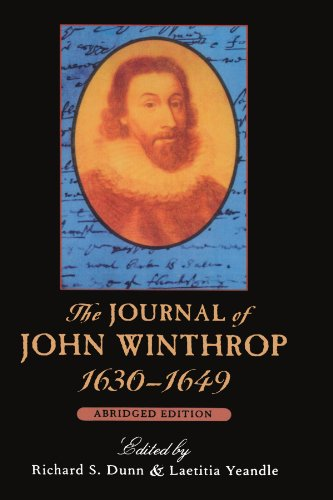Is this book related to Biographies & Memoirs? Yes, this book fits squarely within the 'Biographies & Memoirs' category, offering an in-depth look at the life of one of America's early settlers and leaders. 